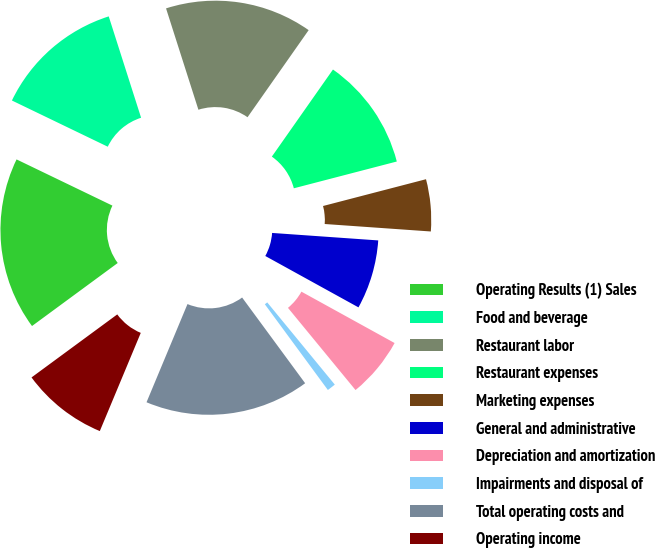Convert chart to OTSL. <chart><loc_0><loc_0><loc_500><loc_500><pie_chart><fcel>Operating Results (1) Sales<fcel>Food and beverage<fcel>Restaurant labor<fcel>Restaurant expenses<fcel>Marketing expenses<fcel>General and administrative<fcel>Depreciation and amortization<fcel>Impairments and disposal of<fcel>Total operating costs and<fcel>Operating income<nl><fcel>17.24%<fcel>12.93%<fcel>14.66%<fcel>11.21%<fcel>5.17%<fcel>6.9%<fcel>6.03%<fcel>0.86%<fcel>16.38%<fcel>8.62%<nl></chart> 